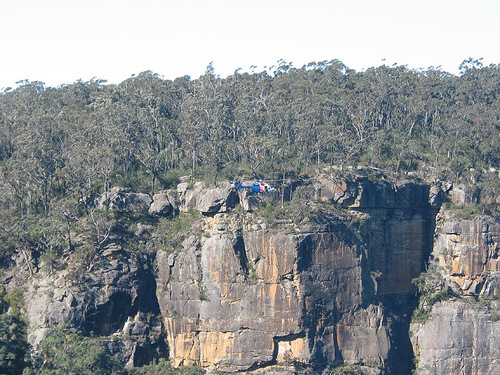<image>
Can you confirm if the sky is behind the helicopter? Yes. From this viewpoint, the sky is positioned behind the helicopter, with the helicopter partially or fully occluding the sky. 